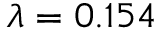Convert formula to latex. <formula><loc_0><loc_0><loc_500><loc_500>\lambda = 0 . 1 5 4</formula> 